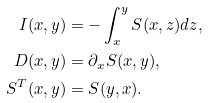Convert formula to latex. <formula><loc_0><loc_0><loc_500><loc_500>I ( x , y ) & = - \int _ { x } ^ { y } S ( x , z ) d z , \\ D ( x , y ) & = \partial _ { x } S ( x , y ) , \\ S ^ { T } ( x , y ) & = S ( y , x ) .</formula> 